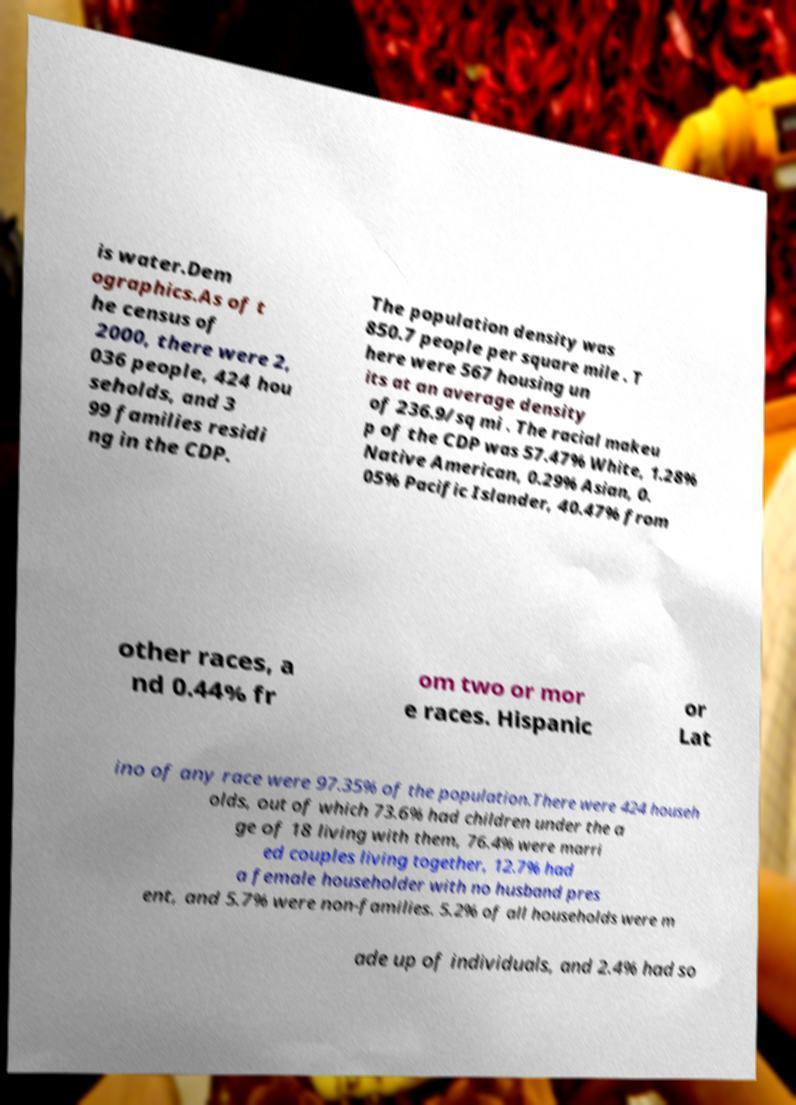What messages or text are displayed in this image? I need them in a readable, typed format. is water.Dem ographics.As of t he census of 2000, there were 2, 036 people, 424 hou seholds, and 3 99 families residi ng in the CDP. The population density was 850.7 people per square mile . T here were 567 housing un its at an average density of 236.9/sq mi . The racial makeu p of the CDP was 57.47% White, 1.28% Native American, 0.29% Asian, 0. 05% Pacific Islander, 40.47% from other races, a nd 0.44% fr om two or mor e races. Hispanic or Lat ino of any race were 97.35% of the population.There were 424 househ olds, out of which 73.6% had children under the a ge of 18 living with them, 76.4% were marri ed couples living together, 12.7% had a female householder with no husband pres ent, and 5.7% were non-families. 5.2% of all households were m ade up of individuals, and 2.4% had so 